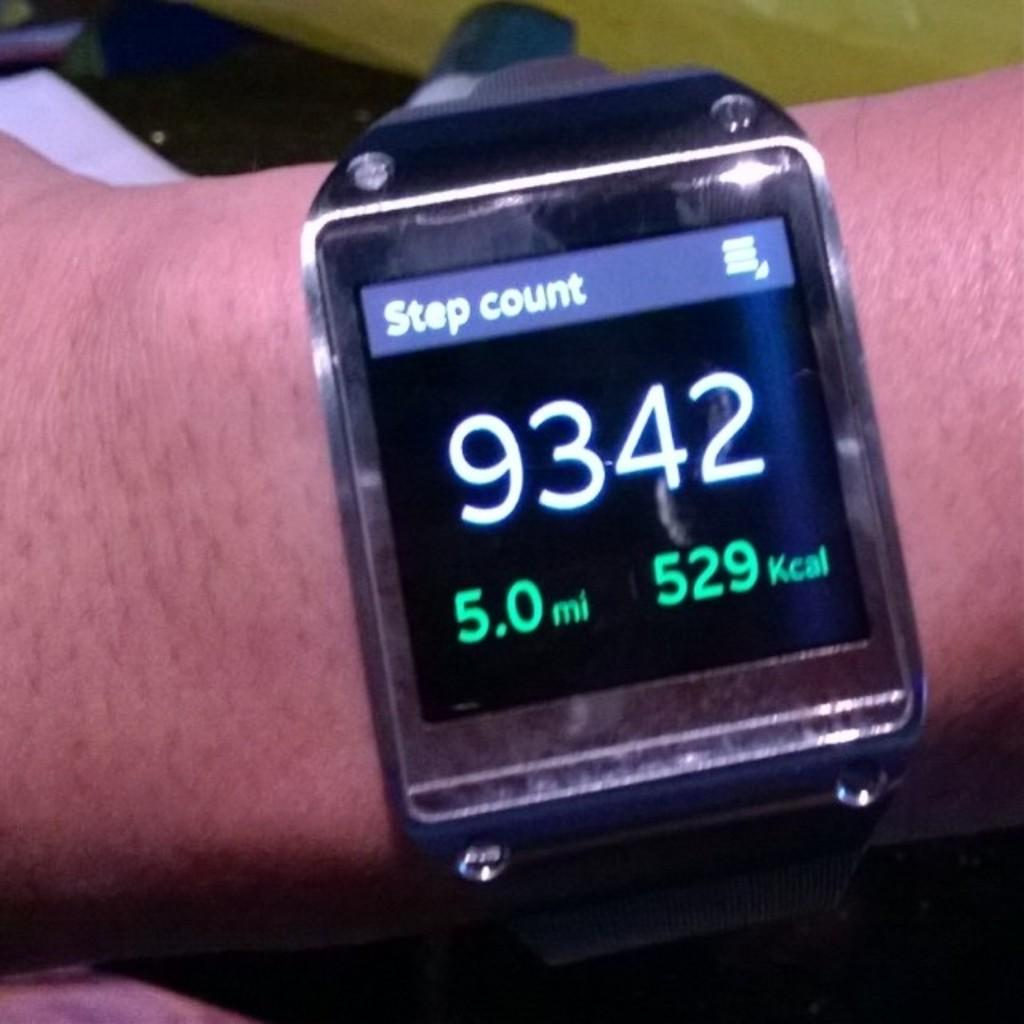<image>
Share a concise interpretation of the image provided. The wrist watch reads that 9342 steps have been made. 